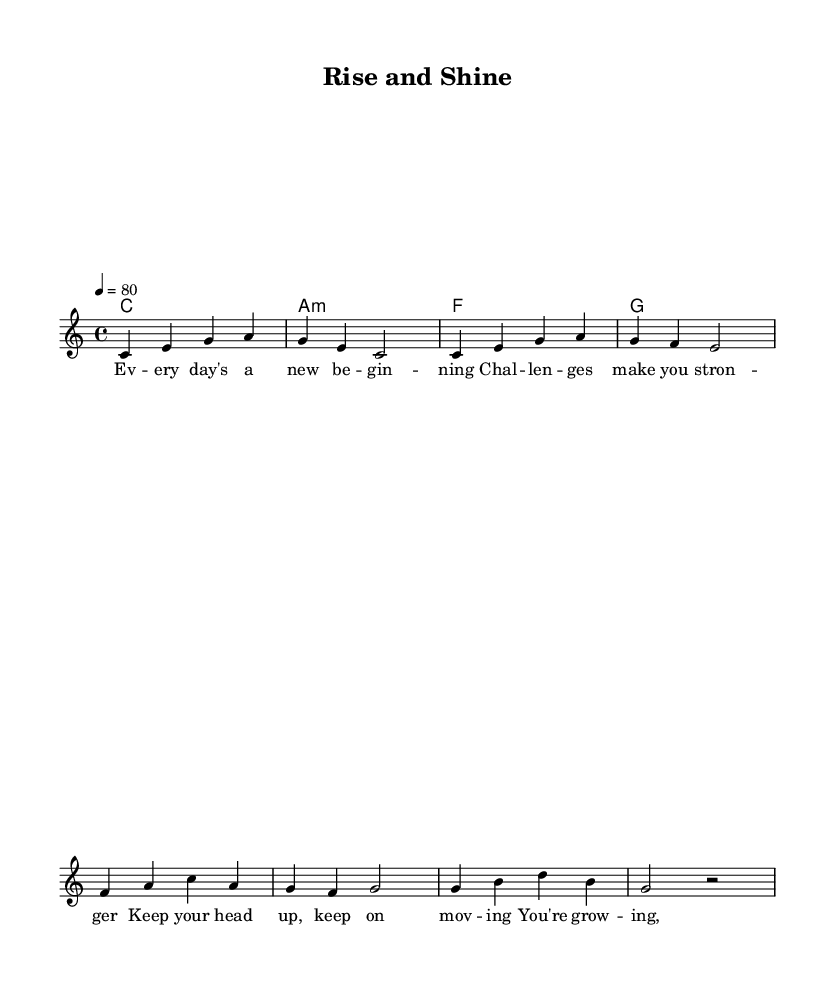What is the key signature of this music? The key signature is indicated at the beginning of the piece. It shows no sharps or flats, which corresponds to C major.
Answer: C major What is the time signature of this music? The time signature appears at the beginning of the piece, represented as a fraction (4/4), indicating four beats in a measure.
Answer: 4/4 What is the tempo marking given for this piece? The tempo is specified in beats per minute at the beginning of the piece as "4 = 80," meaning there are 80 beats in a minute.
Answer: 80 How many measures are there in the melody? To determine the number of measures, we count how many times a vertical line (bar line) appears through the melody. There are 8 measures in total.
Answer: 8 What is the first note of the melody? The first note of the melody is indicated at the start of the melody line, which is a "C."
Answer: C What emotional theme does the song focus on? Analyzing the lyrics provided alongside the melody, the themes revolve around perseverance and personal growth as indicated by phrases like "every day's a new beginning."
Answer: perseverance What type of chords are used in this piece? The chords listed in the chord section indicate they are mainly triads, including a minor chord which is common in reggae music.
Answer: triads 